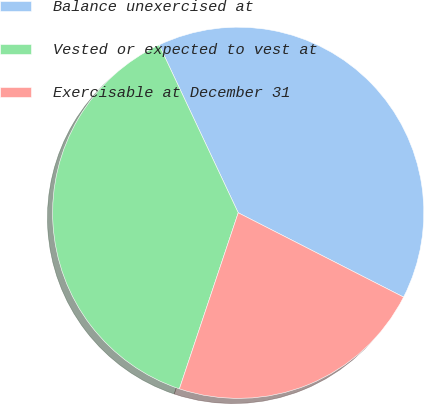Convert chart. <chart><loc_0><loc_0><loc_500><loc_500><pie_chart><fcel>Balance unexercised at<fcel>Vested or expected to vest at<fcel>Exercisable at December 31<nl><fcel>39.51%<fcel>37.86%<fcel>22.63%<nl></chart> 